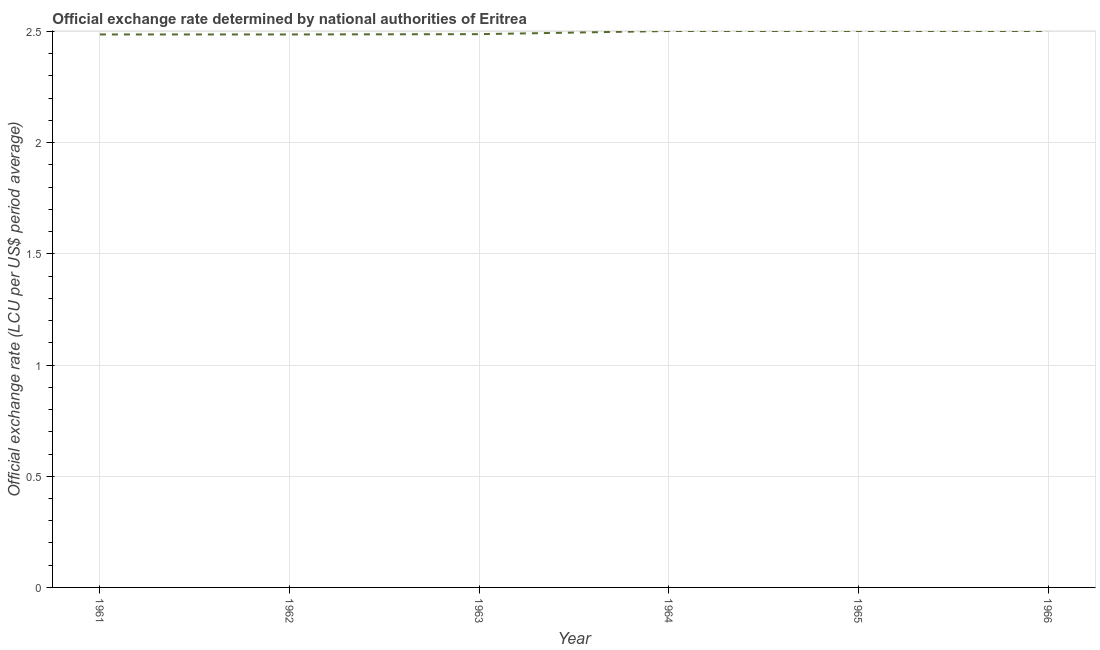What is the official exchange rate in 1962?
Your answer should be compact. 2.49. Across all years, what is the maximum official exchange rate?
Your answer should be very brief. 2.5. Across all years, what is the minimum official exchange rate?
Offer a terse response. 2.49. In which year was the official exchange rate maximum?
Make the answer very short. 1964. What is the sum of the official exchange rate?
Offer a terse response. 14.97. What is the difference between the official exchange rate in 1964 and 1965?
Offer a very short reply. 0. What is the average official exchange rate per year?
Ensure brevity in your answer.  2.49. What is the median official exchange rate?
Make the answer very short. 2.5. What is the ratio of the official exchange rate in 1962 to that in 1966?
Your response must be concise. 0.99. Is the difference between the official exchange rate in 1962 and 1964 greater than the difference between any two years?
Your answer should be very brief. Yes. What is the difference between the highest and the second highest official exchange rate?
Make the answer very short. 0. What is the difference between the highest and the lowest official exchange rate?
Your response must be concise. 0.02. In how many years, is the official exchange rate greater than the average official exchange rate taken over all years?
Give a very brief answer. 3. What is the title of the graph?
Your answer should be compact. Official exchange rate determined by national authorities of Eritrea. What is the label or title of the Y-axis?
Provide a succinct answer. Official exchange rate (LCU per US$ period average). What is the Official exchange rate (LCU per US$ period average) of 1961?
Your response must be concise. 2.49. What is the Official exchange rate (LCU per US$ period average) in 1962?
Provide a short and direct response. 2.49. What is the Official exchange rate (LCU per US$ period average) in 1963?
Your response must be concise. 2.49. What is the Official exchange rate (LCU per US$ period average) in 1964?
Provide a short and direct response. 2.5. What is the Official exchange rate (LCU per US$ period average) in 1965?
Make the answer very short. 2.5. What is the Official exchange rate (LCU per US$ period average) in 1966?
Offer a very short reply. 2.5. What is the difference between the Official exchange rate (LCU per US$ period average) in 1961 and 1963?
Offer a terse response. -0. What is the difference between the Official exchange rate (LCU per US$ period average) in 1961 and 1964?
Give a very brief answer. -0.02. What is the difference between the Official exchange rate (LCU per US$ period average) in 1961 and 1965?
Keep it short and to the point. -0.02. What is the difference between the Official exchange rate (LCU per US$ period average) in 1961 and 1966?
Make the answer very short. -0.02. What is the difference between the Official exchange rate (LCU per US$ period average) in 1962 and 1963?
Offer a terse response. -0. What is the difference between the Official exchange rate (LCU per US$ period average) in 1962 and 1964?
Provide a short and direct response. -0.02. What is the difference between the Official exchange rate (LCU per US$ period average) in 1962 and 1965?
Offer a terse response. -0.02. What is the difference between the Official exchange rate (LCU per US$ period average) in 1962 and 1966?
Make the answer very short. -0.02. What is the difference between the Official exchange rate (LCU per US$ period average) in 1963 and 1964?
Keep it short and to the point. -0.01. What is the difference between the Official exchange rate (LCU per US$ period average) in 1963 and 1965?
Offer a terse response. -0.01. What is the difference between the Official exchange rate (LCU per US$ period average) in 1963 and 1966?
Your response must be concise. -0.01. What is the difference between the Official exchange rate (LCU per US$ period average) in 1964 and 1966?
Provide a short and direct response. 0. What is the ratio of the Official exchange rate (LCU per US$ period average) in 1961 to that in 1962?
Give a very brief answer. 1. What is the ratio of the Official exchange rate (LCU per US$ period average) in 1961 to that in 1963?
Your answer should be very brief. 1. What is the ratio of the Official exchange rate (LCU per US$ period average) in 1961 to that in 1966?
Ensure brevity in your answer.  0.99. What is the ratio of the Official exchange rate (LCU per US$ period average) in 1963 to that in 1964?
Provide a succinct answer. 0.99. What is the ratio of the Official exchange rate (LCU per US$ period average) in 1963 to that in 1965?
Your response must be concise. 0.99. What is the ratio of the Official exchange rate (LCU per US$ period average) in 1963 to that in 1966?
Provide a short and direct response. 0.99. What is the ratio of the Official exchange rate (LCU per US$ period average) in 1964 to that in 1965?
Give a very brief answer. 1. 